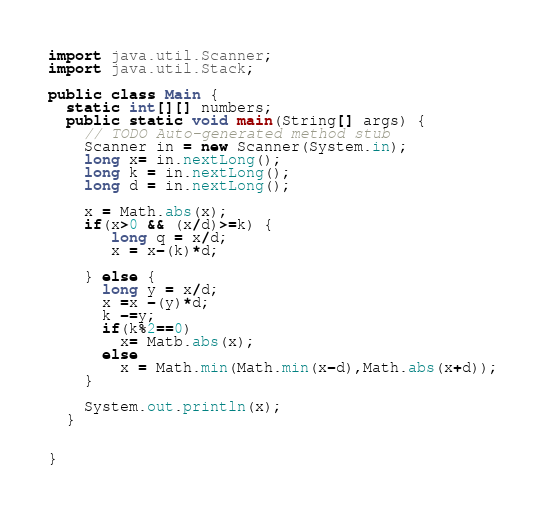Convert code to text. <code><loc_0><loc_0><loc_500><loc_500><_Java_>
import java.util.Scanner;
import java.util.Stack;

public class Main {
  static int[][] numbers;
  public static void main(String[] args) {
    // TODO Auto-generated method stub
    Scanner in = new Scanner(System.in);
    long x= in.nextLong();
    long k = in.nextLong();
    long d = in.nextLong();

    x = Math.abs(x);
    if(x>0 && (x/d)>=k) {
       long q = x/d;
       x = x-(k)*d;

    } else {
      long y = x/d;
      x =x -(y)*d;
      k -=y;
      if(k%2==0)
        x= Matb.abs(x);
      else
        x = Math.min(Math.min(x-d),Math.abs(x+d));
    }

    System.out.println(x);     
  }
  
  
}</code> 